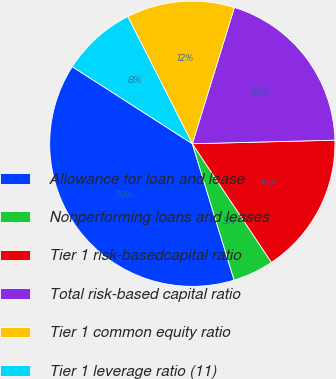Convert chart to OTSL. <chart><loc_0><loc_0><loc_500><loc_500><pie_chart><fcel>Allowance for loan and lease<fcel>Nonperforming loans and leases<fcel>Tier 1 risk-basedcapital ratio<fcel>Total risk-based capital ratio<fcel>Tier 1 common equity ratio<fcel>Tier 1 leverage ratio (11)<nl><fcel>38.82%<fcel>4.63%<fcel>16.04%<fcel>19.84%<fcel>12.24%<fcel>8.44%<nl></chart> 